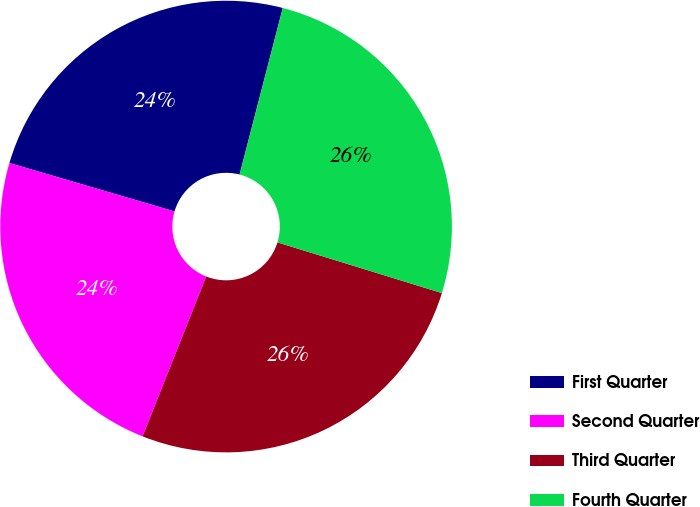Convert chart. <chart><loc_0><loc_0><loc_500><loc_500><pie_chart><fcel>First Quarter<fcel>Second Quarter<fcel>Third Quarter<fcel>Fourth Quarter<nl><fcel>24.5%<fcel>23.51%<fcel>26.27%<fcel>25.72%<nl></chart> 